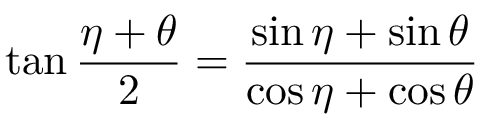<formula> <loc_0><loc_0><loc_500><loc_500>\tan { \frac { \eta + \theta } { 2 } } = { \frac { \sin \eta + \sin \theta } { \cos \eta + \cos \theta } }</formula> 